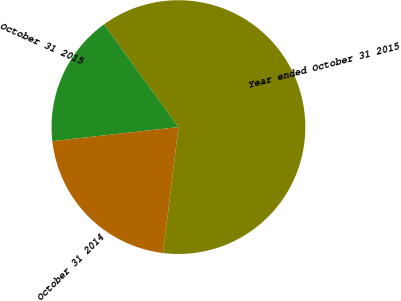Convert chart to OTSL. <chart><loc_0><loc_0><loc_500><loc_500><pie_chart><fcel>Year ended October 31 2015<fcel>October 31 2015<fcel>October 31 2014<nl><fcel>61.91%<fcel>16.79%<fcel>21.3%<nl></chart> 